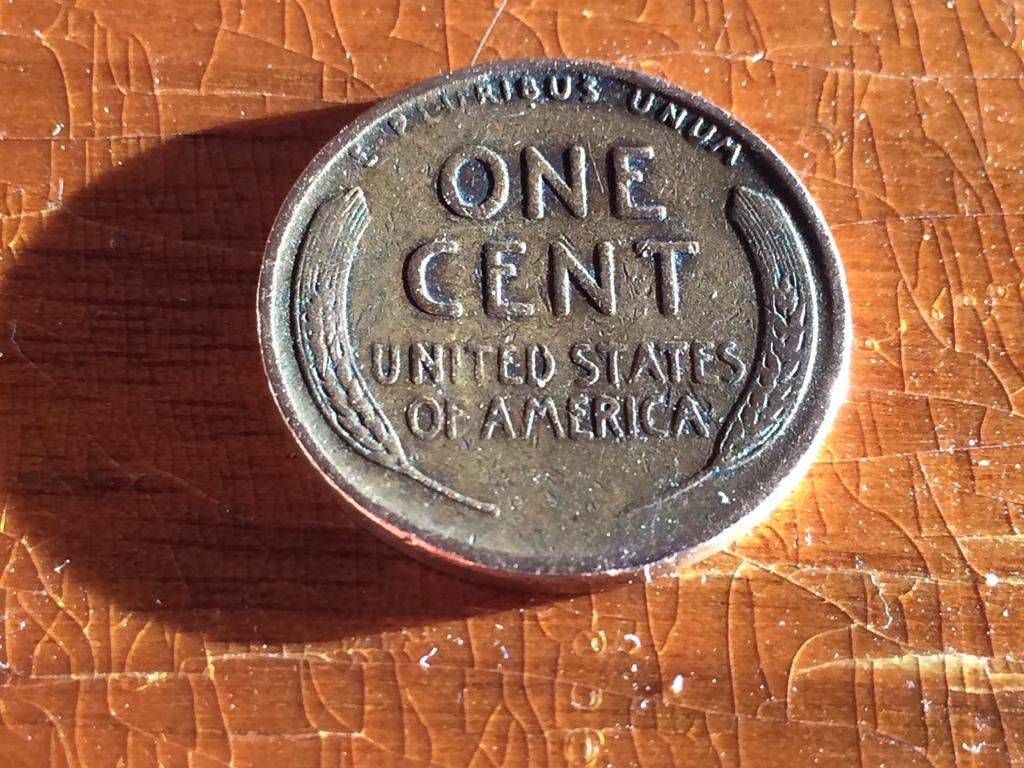What object is present in the image that has monetary value? There is a coin in the image. What can be seen on the surface of the coin? There is writing on the coin. What is the background or surface on which the coin is placed? The coin is on a brown color board. Can you hear the sound of thunder in the image? There is no sound present in the image, as it is a static visual representation. Is there a screw visible on the coin in the image? There is no screw present on the coin in the image. 